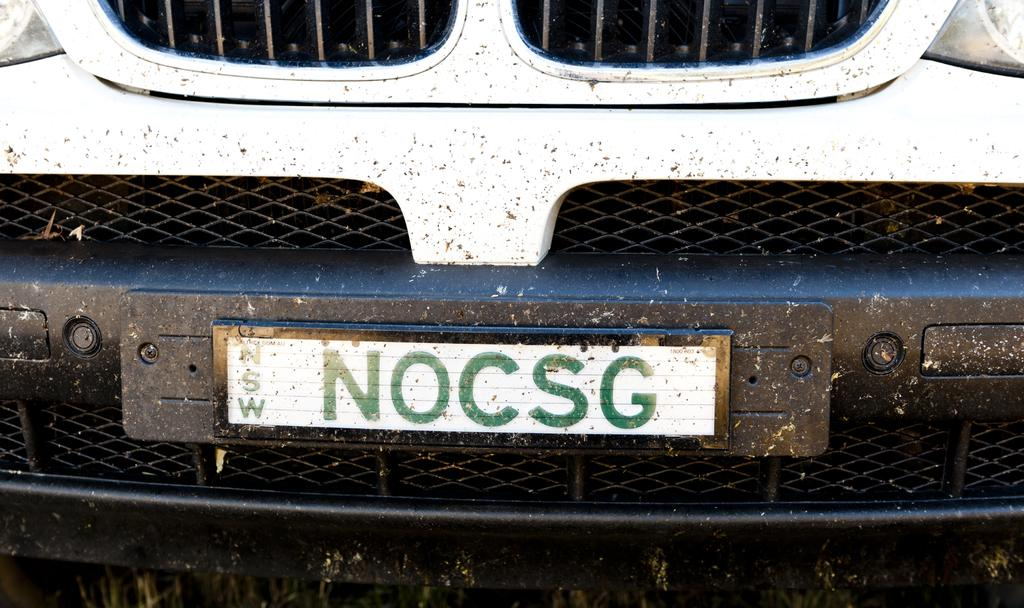<image>
Give a short and clear explanation of the subsequent image. NOCSG is on a license plate on a white vehicle. 